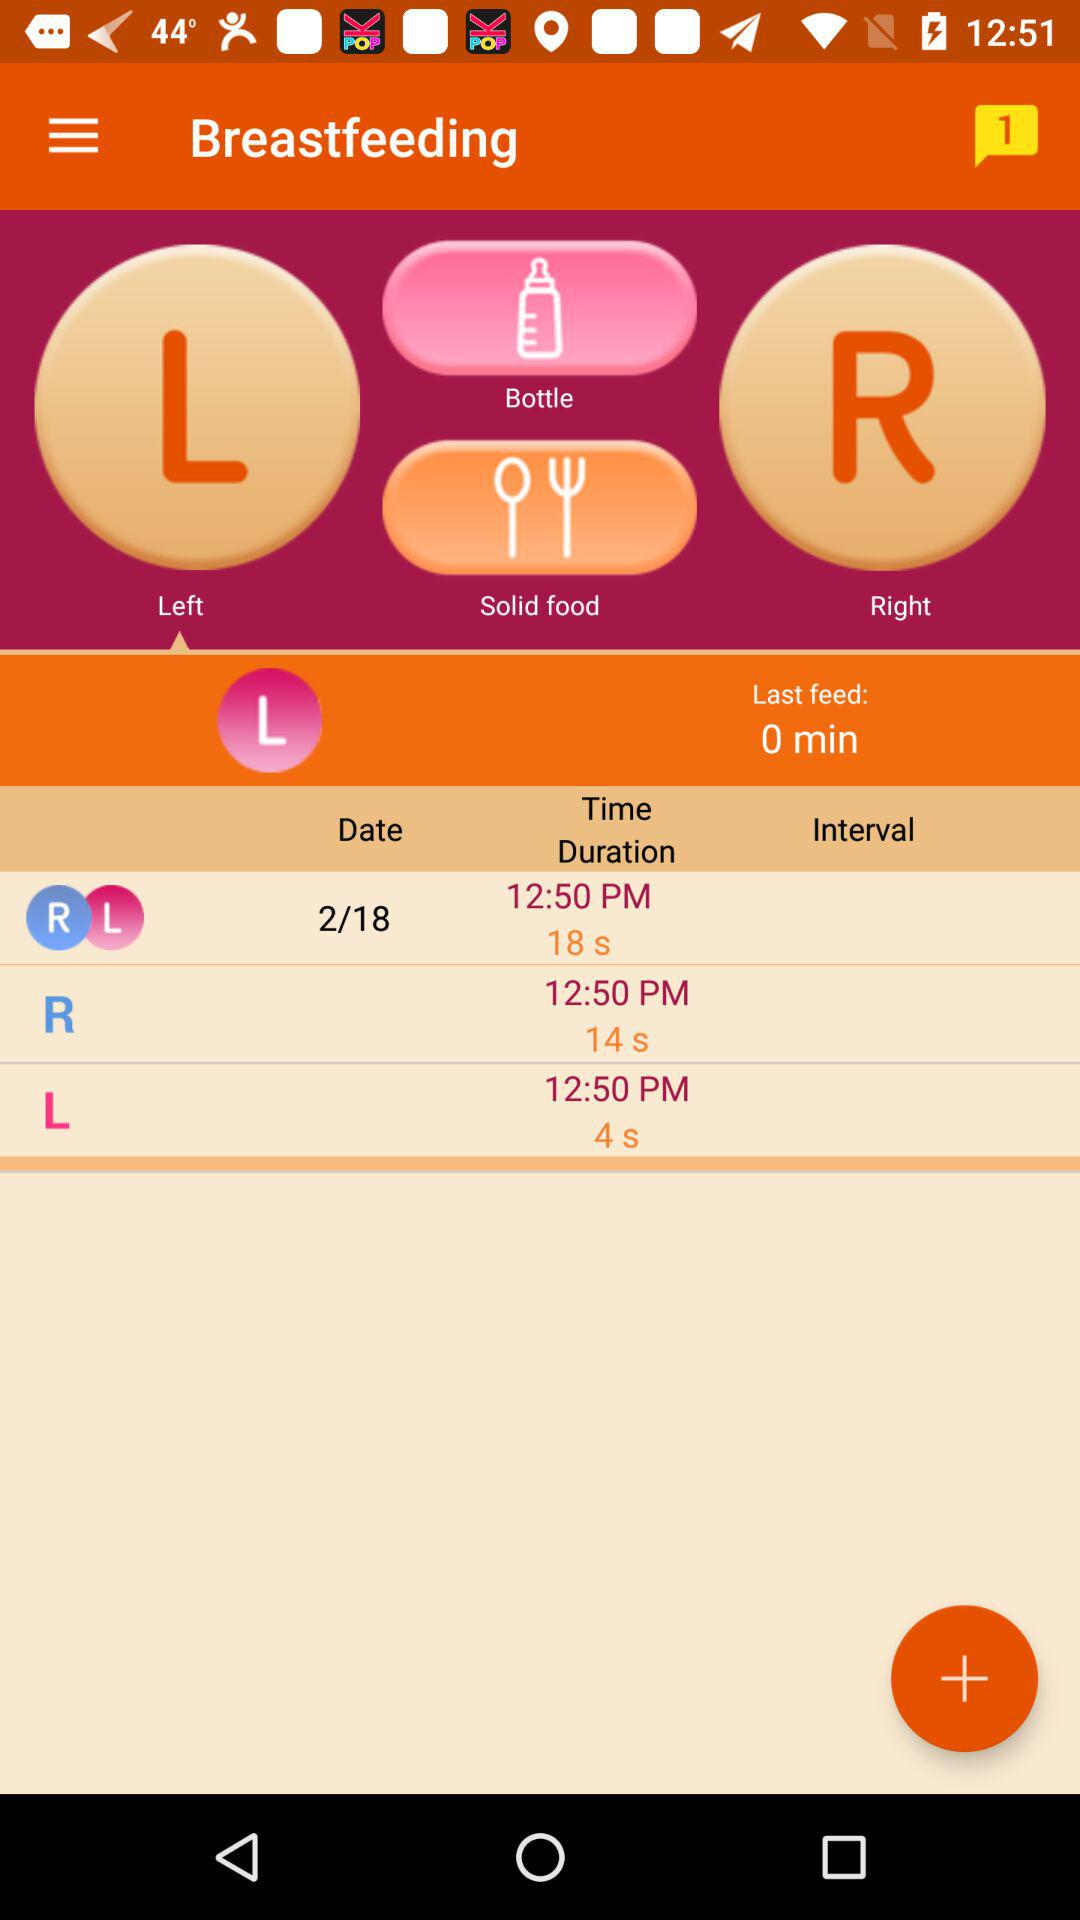What are the different time durations? The different time durations are 18 seconds, 14 seconds and 4 seconds. 